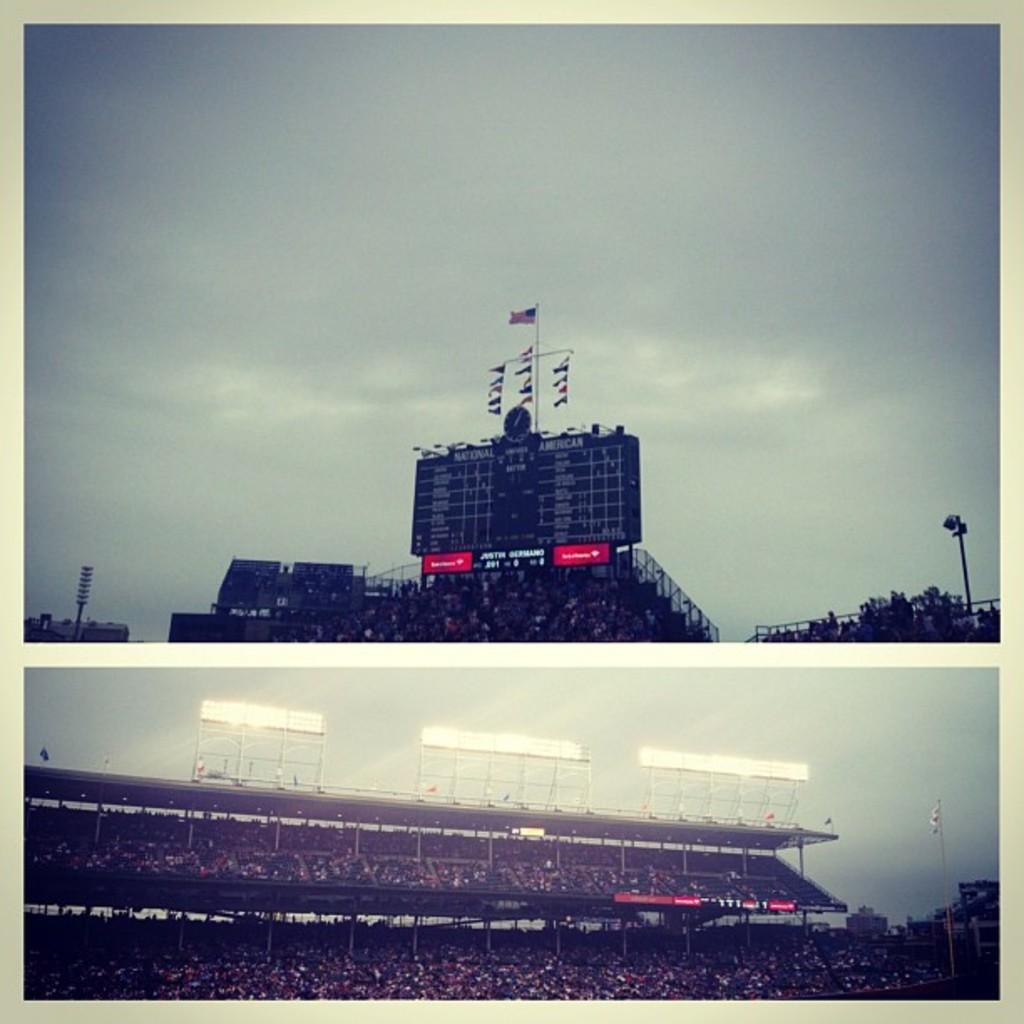Describe this image in one or two sentences. This is the collage image of two pictures. The image which is at the top there are boards with some text written on it and there are flags, poles and trees and there are buildings and the sky is cloudy and the image which is at the bottom, there are a person's, lights, boards and there is a flag and the sky is cloudy. 